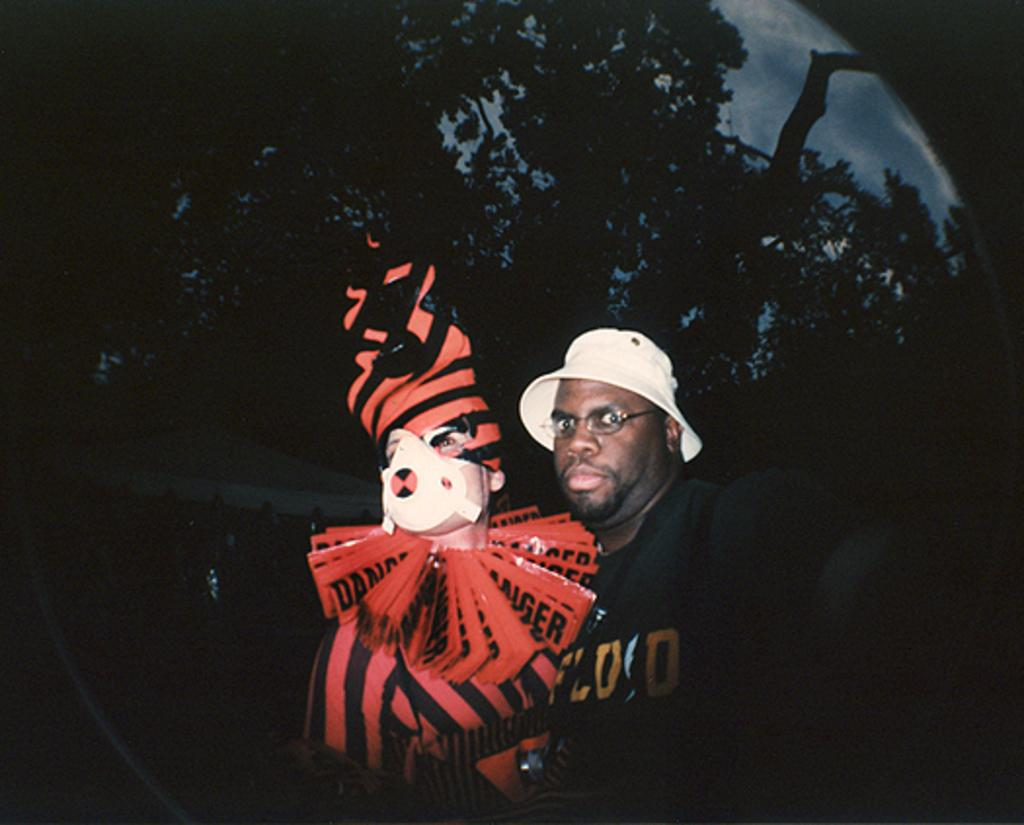What is being reflected in the image? There is a reflection of two persons, a tree, and the sky in the image. What is the nature of the reflection? The reflection is on an object. What type of leaf is being suggested as a territory in the image? There is no leaf, suggestion, or territory present in the image. 